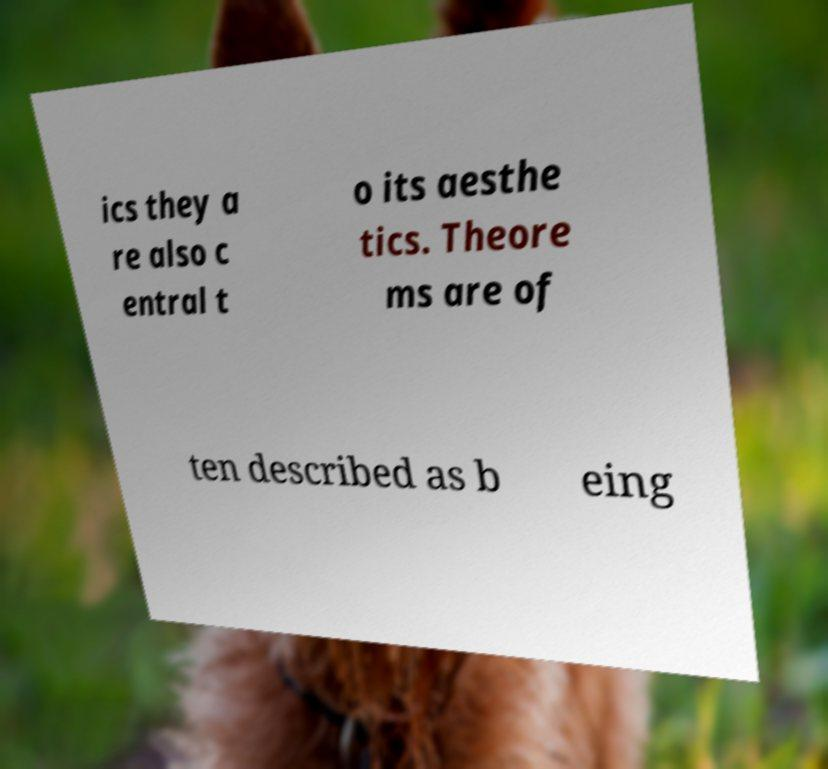Could you assist in decoding the text presented in this image and type it out clearly? ics they a re also c entral t o its aesthe tics. Theore ms are of ten described as b eing 